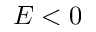Convert formula to latex. <formula><loc_0><loc_0><loc_500><loc_500>E < 0</formula> 